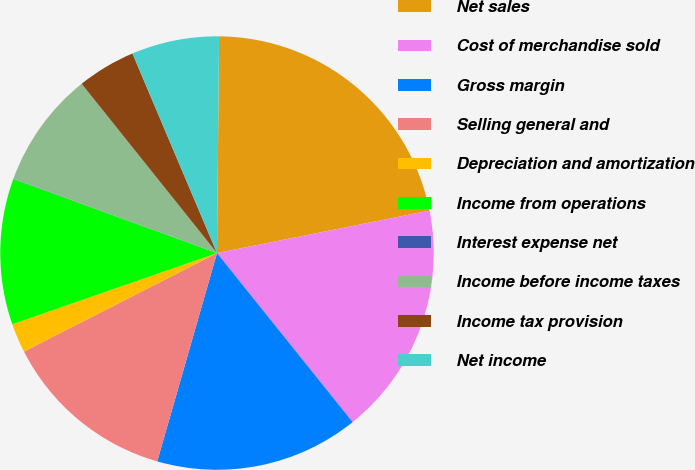<chart> <loc_0><loc_0><loc_500><loc_500><pie_chart><fcel>Net sales<fcel>Cost of merchandise sold<fcel>Gross margin<fcel>Selling general and<fcel>Depreciation and amortization<fcel>Income from operations<fcel>Interest expense net<fcel>Income before income taxes<fcel>Income tax provision<fcel>Net income<nl><fcel>21.71%<fcel>17.38%<fcel>15.21%<fcel>13.04%<fcel>2.19%<fcel>10.87%<fcel>0.02%<fcel>8.7%<fcel>4.36%<fcel>6.53%<nl></chart> 